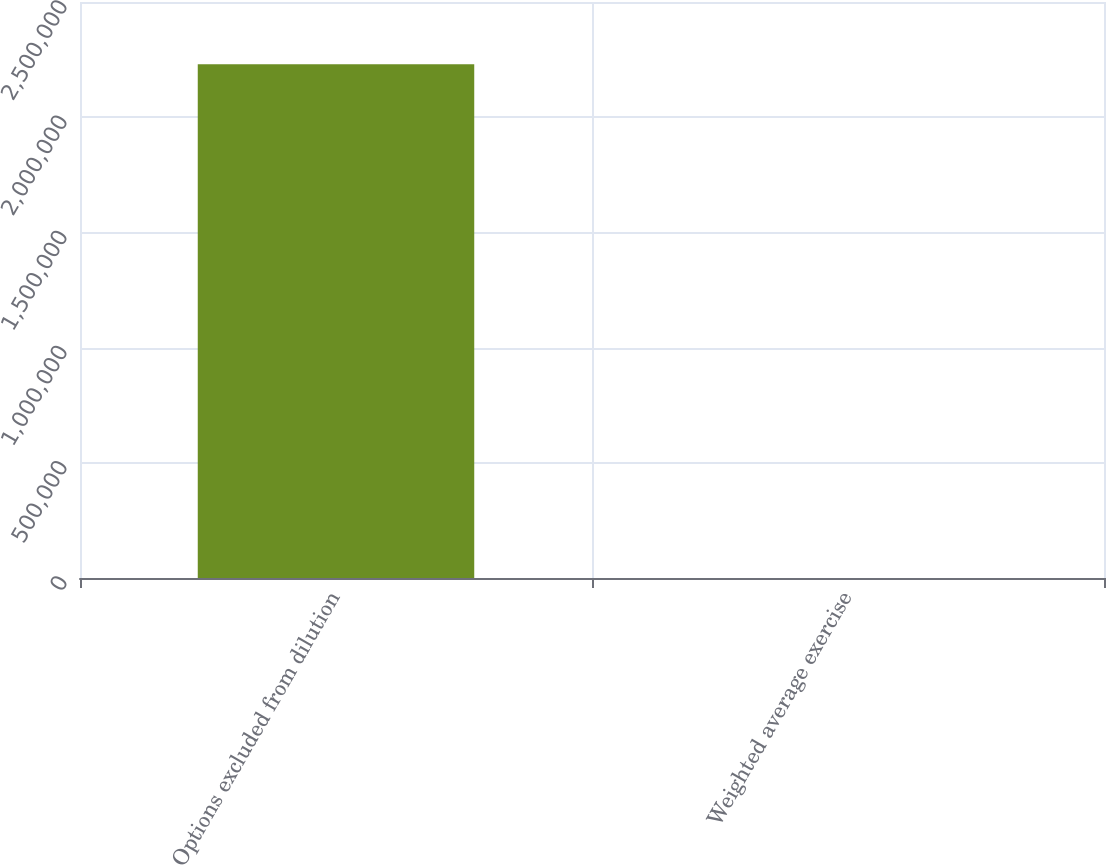Convert chart to OTSL. <chart><loc_0><loc_0><loc_500><loc_500><bar_chart><fcel>Options excluded from dilution<fcel>Weighted average exercise<nl><fcel>2.22998e+06<fcel>39.77<nl></chart> 